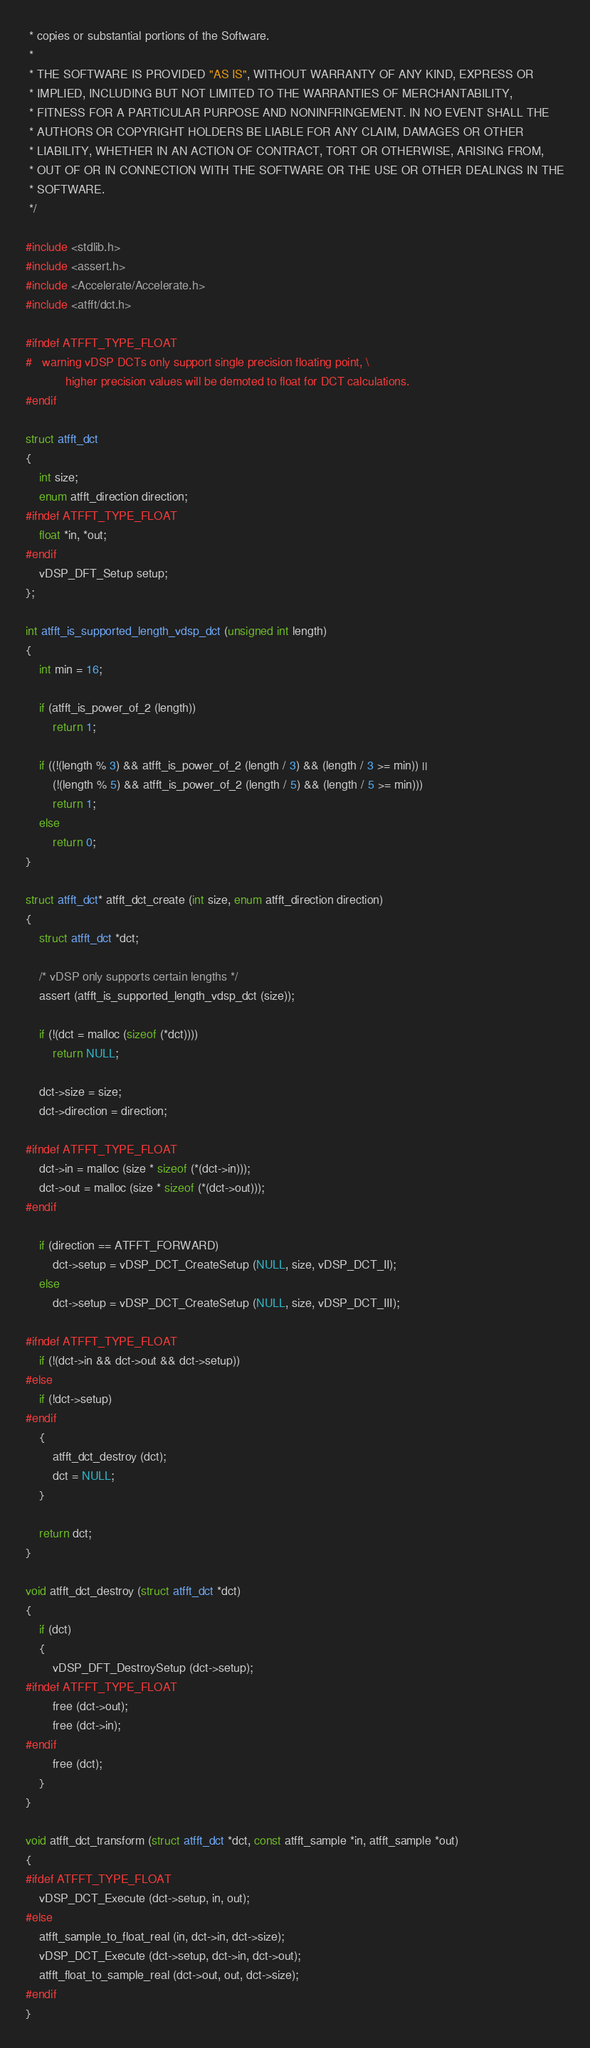<code> <loc_0><loc_0><loc_500><loc_500><_C_> * copies or substantial portions of the Software.
 *
 * THE SOFTWARE IS PROVIDED "AS IS", WITHOUT WARRANTY OF ANY KIND, EXPRESS OR
 * IMPLIED, INCLUDING BUT NOT LIMITED TO THE WARRANTIES OF MERCHANTABILITY,
 * FITNESS FOR A PARTICULAR PURPOSE AND NONINFRINGEMENT. IN NO EVENT SHALL THE
 * AUTHORS OR COPYRIGHT HOLDERS BE LIABLE FOR ANY CLAIM, DAMAGES OR OTHER
 * LIABILITY, WHETHER IN AN ACTION OF CONTRACT, TORT OR OTHERWISE, ARISING FROM,
 * OUT OF OR IN CONNECTION WITH THE SOFTWARE OR THE USE OR OTHER DEALINGS IN THE
 * SOFTWARE.
 */

#include <stdlib.h>
#include <assert.h>
#include <Accelerate/Accelerate.h>
#include <atfft/dct.h>

#ifndef ATFFT_TYPE_FLOAT
#   warning vDSP DCTs only support single precision floating point, \
            higher precision values will be demoted to float for DCT calculations.
#endif

struct atfft_dct
{
    int size;
    enum atfft_direction direction;
#ifndef ATFFT_TYPE_FLOAT
    float *in, *out;
#endif
    vDSP_DFT_Setup setup;
};

int atfft_is_supported_length_vdsp_dct (unsigned int length)
{
    int min = 16;

    if (atfft_is_power_of_2 (length))
        return 1;

    if ((!(length % 3) && atfft_is_power_of_2 (length / 3) && (length / 3 >= min)) ||
        (!(length % 5) && atfft_is_power_of_2 (length / 5) && (length / 5 >= min)))
        return 1;        
    else
        return 0;
}

struct atfft_dct* atfft_dct_create (int size, enum atfft_direction direction)
{
    struct atfft_dct *dct;

    /* vDSP only supports certain lengths */
    assert (atfft_is_supported_length_vdsp_dct (size));

    if (!(dct = malloc (sizeof (*dct))))
        return NULL;

    dct->size = size;
    dct->direction = direction;

#ifndef ATFFT_TYPE_FLOAT
    dct->in = malloc (size * sizeof (*(dct->in)));
    dct->out = malloc (size * sizeof (*(dct->out)));
#endif

    if (direction == ATFFT_FORWARD)
        dct->setup = vDSP_DCT_CreateSetup (NULL, size, vDSP_DCT_II);
    else
        dct->setup = vDSP_DCT_CreateSetup (NULL, size, vDSP_DCT_III);

#ifndef ATFFT_TYPE_FLOAT
    if (!(dct->in && dct->out && dct->setup))
#else
    if (!dct->setup)
#endif
    {
        atfft_dct_destroy (dct);
        dct = NULL;
    }

    return dct;
}

void atfft_dct_destroy (struct atfft_dct *dct)
{
    if (dct)
    {
        vDSP_DFT_DestroySetup (dct->setup);
#ifndef ATFFT_TYPE_FLOAT
        free (dct->out);
        free (dct->in);
#endif
        free (dct);
    }
}

void atfft_dct_transform (struct atfft_dct *dct, const atfft_sample *in, atfft_sample *out)
{
#ifdef ATFFT_TYPE_FLOAT
    vDSP_DCT_Execute (dct->setup, in, out);
#else
    atfft_sample_to_float_real (in, dct->in, dct->size);
    vDSP_DCT_Execute (dct->setup, dct->in, dct->out);
    atfft_float_to_sample_real (dct->out, out, dct->size);
#endif
}
</code> 